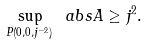<formula> <loc_0><loc_0><loc_500><loc_500>\sup _ { P ( 0 , 0 , j ^ { - 2 } ) } \ a b s { A } \geq j ^ { 2 } .</formula> 